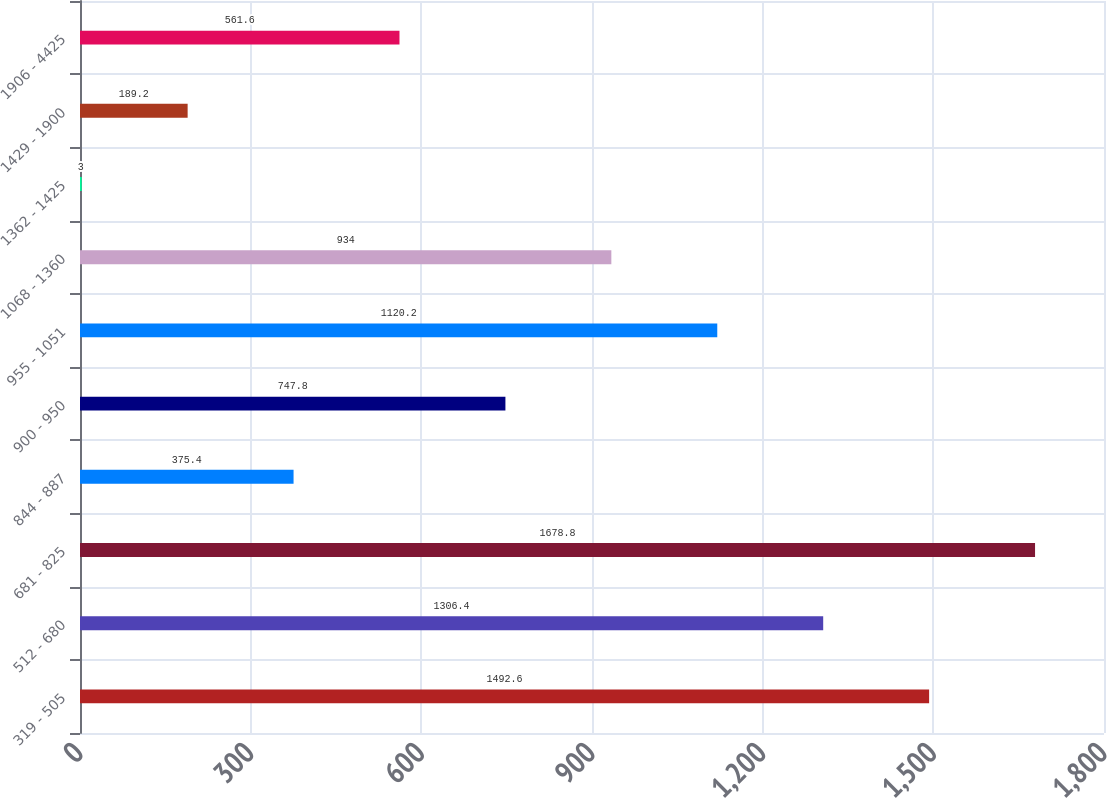Convert chart to OTSL. <chart><loc_0><loc_0><loc_500><loc_500><bar_chart><fcel>319 - 505<fcel>512 - 680<fcel>681 - 825<fcel>844 - 887<fcel>900 - 950<fcel>955 - 1051<fcel>1068 - 1360<fcel>1362 - 1425<fcel>1429 - 1900<fcel>1906 - 4425<nl><fcel>1492.6<fcel>1306.4<fcel>1678.8<fcel>375.4<fcel>747.8<fcel>1120.2<fcel>934<fcel>3<fcel>189.2<fcel>561.6<nl></chart> 